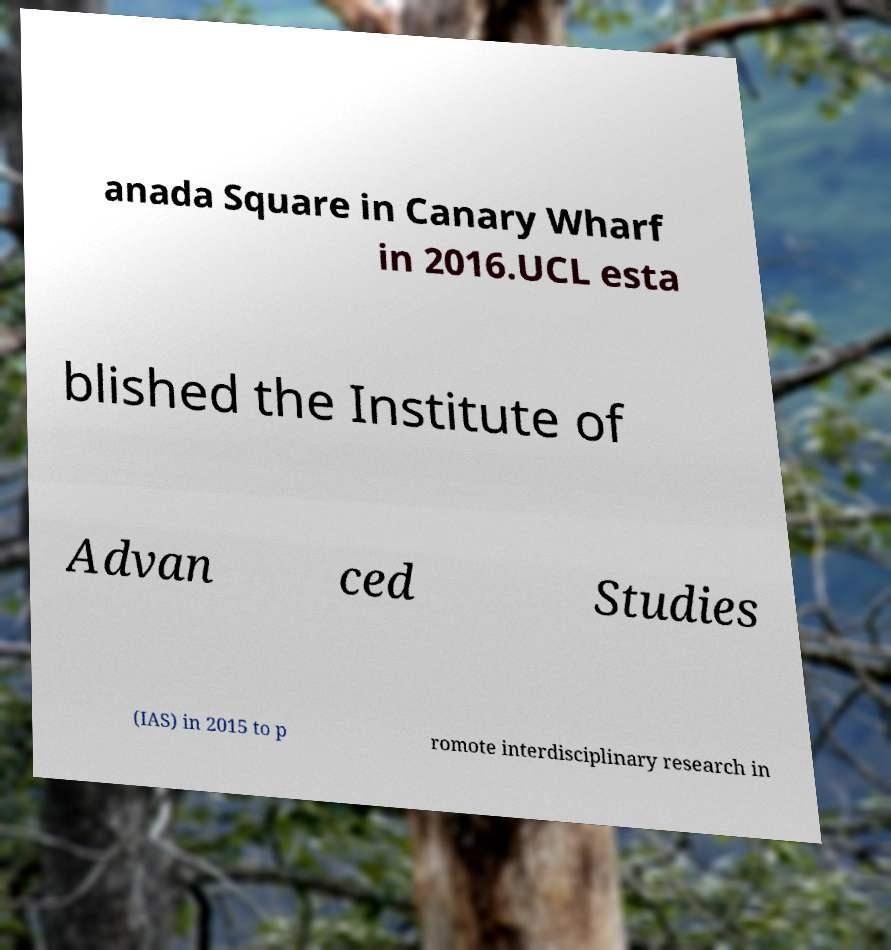I need the written content from this picture converted into text. Can you do that? anada Square in Canary Wharf in 2016.UCL esta blished the Institute of Advan ced Studies (IAS) in 2015 to p romote interdisciplinary research in 